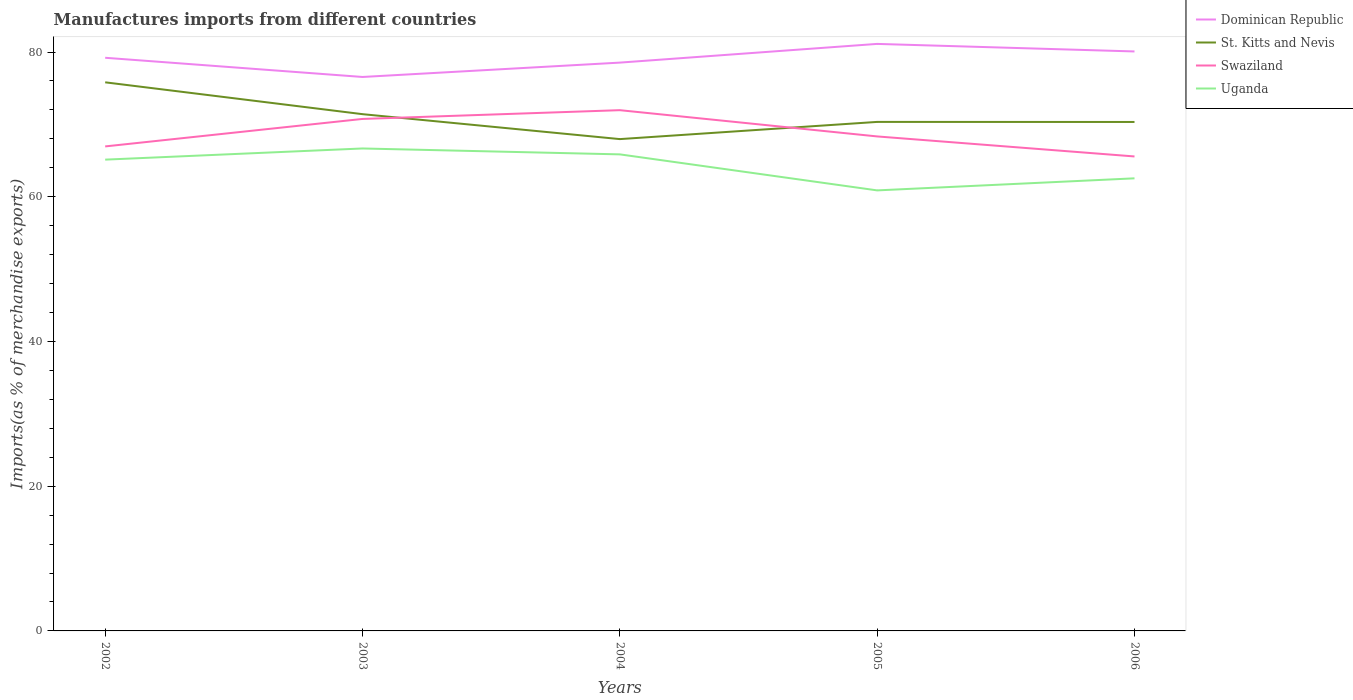Does the line corresponding to Uganda intersect with the line corresponding to St. Kitts and Nevis?
Ensure brevity in your answer.  No. Across all years, what is the maximum percentage of imports to different countries in St. Kitts and Nevis?
Offer a terse response. 67.97. What is the total percentage of imports to different countries in Swaziland in the graph?
Provide a succinct answer. -5.01. What is the difference between the highest and the second highest percentage of imports to different countries in Dominican Republic?
Provide a short and direct response. 4.57. Is the percentage of imports to different countries in St. Kitts and Nevis strictly greater than the percentage of imports to different countries in Dominican Republic over the years?
Make the answer very short. Yes. How many years are there in the graph?
Your response must be concise. 5. Are the values on the major ticks of Y-axis written in scientific E-notation?
Your response must be concise. No. What is the title of the graph?
Ensure brevity in your answer.  Manufactures imports from different countries. What is the label or title of the X-axis?
Offer a terse response. Years. What is the label or title of the Y-axis?
Give a very brief answer. Imports(as % of merchandise exports). What is the Imports(as % of merchandise exports) in Dominican Republic in 2002?
Offer a very short reply. 79.21. What is the Imports(as % of merchandise exports) of St. Kitts and Nevis in 2002?
Your answer should be very brief. 75.82. What is the Imports(as % of merchandise exports) of Swaziland in 2002?
Your response must be concise. 66.96. What is the Imports(as % of merchandise exports) in Uganda in 2002?
Your answer should be compact. 65.13. What is the Imports(as % of merchandise exports) of Dominican Republic in 2003?
Provide a succinct answer. 76.56. What is the Imports(as % of merchandise exports) in St. Kitts and Nevis in 2003?
Provide a short and direct response. 71.41. What is the Imports(as % of merchandise exports) of Swaziland in 2003?
Your answer should be compact. 70.76. What is the Imports(as % of merchandise exports) in Uganda in 2003?
Your response must be concise. 66.67. What is the Imports(as % of merchandise exports) in Dominican Republic in 2004?
Your answer should be compact. 78.54. What is the Imports(as % of merchandise exports) in St. Kitts and Nevis in 2004?
Your answer should be compact. 67.97. What is the Imports(as % of merchandise exports) of Swaziland in 2004?
Keep it short and to the point. 71.97. What is the Imports(as % of merchandise exports) of Uganda in 2004?
Offer a terse response. 65.86. What is the Imports(as % of merchandise exports) of Dominican Republic in 2005?
Offer a terse response. 81.12. What is the Imports(as % of merchandise exports) in St. Kitts and Nevis in 2005?
Your response must be concise. 70.34. What is the Imports(as % of merchandise exports) of Swaziland in 2005?
Provide a succinct answer. 68.34. What is the Imports(as % of merchandise exports) of Uganda in 2005?
Offer a terse response. 60.88. What is the Imports(as % of merchandise exports) of Dominican Republic in 2006?
Make the answer very short. 80.08. What is the Imports(as % of merchandise exports) of St. Kitts and Nevis in 2006?
Offer a terse response. 70.34. What is the Imports(as % of merchandise exports) of Swaziland in 2006?
Your answer should be compact. 65.57. What is the Imports(as % of merchandise exports) of Uganda in 2006?
Provide a succinct answer. 62.55. Across all years, what is the maximum Imports(as % of merchandise exports) of Dominican Republic?
Offer a very short reply. 81.12. Across all years, what is the maximum Imports(as % of merchandise exports) of St. Kitts and Nevis?
Offer a terse response. 75.82. Across all years, what is the maximum Imports(as % of merchandise exports) in Swaziland?
Your response must be concise. 71.97. Across all years, what is the maximum Imports(as % of merchandise exports) in Uganda?
Ensure brevity in your answer.  66.67. Across all years, what is the minimum Imports(as % of merchandise exports) in Dominican Republic?
Give a very brief answer. 76.56. Across all years, what is the minimum Imports(as % of merchandise exports) of St. Kitts and Nevis?
Keep it short and to the point. 67.97. Across all years, what is the minimum Imports(as % of merchandise exports) of Swaziland?
Offer a terse response. 65.57. Across all years, what is the minimum Imports(as % of merchandise exports) of Uganda?
Offer a very short reply. 60.88. What is the total Imports(as % of merchandise exports) of Dominican Republic in the graph?
Your answer should be compact. 395.51. What is the total Imports(as % of merchandise exports) of St. Kitts and Nevis in the graph?
Provide a succinct answer. 355.88. What is the total Imports(as % of merchandise exports) of Swaziland in the graph?
Ensure brevity in your answer.  343.59. What is the total Imports(as % of merchandise exports) in Uganda in the graph?
Provide a succinct answer. 321.09. What is the difference between the Imports(as % of merchandise exports) of Dominican Republic in 2002 and that in 2003?
Offer a very short reply. 2.65. What is the difference between the Imports(as % of merchandise exports) in St. Kitts and Nevis in 2002 and that in 2003?
Provide a succinct answer. 4.4. What is the difference between the Imports(as % of merchandise exports) in Swaziland in 2002 and that in 2003?
Keep it short and to the point. -3.8. What is the difference between the Imports(as % of merchandise exports) in Uganda in 2002 and that in 2003?
Your answer should be compact. -1.54. What is the difference between the Imports(as % of merchandise exports) of Dominican Republic in 2002 and that in 2004?
Make the answer very short. 0.67. What is the difference between the Imports(as % of merchandise exports) of St. Kitts and Nevis in 2002 and that in 2004?
Make the answer very short. 7.85. What is the difference between the Imports(as % of merchandise exports) in Swaziland in 2002 and that in 2004?
Your answer should be compact. -5.01. What is the difference between the Imports(as % of merchandise exports) in Uganda in 2002 and that in 2004?
Make the answer very short. -0.73. What is the difference between the Imports(as % of merchandise exports) in Dominican Republic in 2002 and that in 2005?
Provide a succinct answer. -1.92. What is the difference between the Imports(as % of merchandise exports) in St. Kitts and Nevis in 2002 and that in 2005?
Provide a succinct answer. 5.47. What is the difference between the Imports(as % of merchandise exports) in Swaziland in 2002 and that in 2005?
Offer a terse response. -1.38. What is the difference between the Imports(as % of merchandise exports) in Uganda in 2002 and that in 2005?
Provide a succinct answer. 4.25. What is the difference between the Imports(as % of merchandise exports) of Dominican Republic in 2002 and that in 2006?
Make the answer very short. -0.87. What is the difference between the Imports(as % of merchandise exports) of St. Kitts and Nevis in 2002 and that in 2006?
Provide a succinct answer. 5.48. What is the difference between the Imports(as % of merchandise exports) in Swaziland in 2002 and that in 2006?
Your answer should be very brief. 1.39. What is the difference between the Imports(as % of merchandise exports) in Uganda in 2002 and that in 2006?
Give a very brief answer. 2.58. What is the difference between the Imports(as % of merchandise exports) of Dominican Republic in 2003 and that in 2004?
Ensure brevity in your answer.  -1.98. What is the difference between the Imports(as % of merchandise exports) in St. Kitts and Nevis in 2003 and that in 2004?
Ensure brevity in your answer.  3.45. What is the difference between the Imports(as % of merchandise exports) in Swaziland in 2003 and that in 2004?
Provide a short and direct response. -1.21. What is the difference between the Imports(as % of merchandise exports) in Uganda in 2003 and that in 2004?
Give a very brief answer. 0.82. What is the difference between the Imports(as % of merchandise exports) in Dominican Republic in 2003 and that in 2005?
Ensure brevity in your answer.  -4.57. What is the difference between the Imports(as % of merchandise exports) in St. Kitts and Nevis in 2003 and that in 2005?
Make the answer very short. 1.07. What is the difference between the Imports(as % of merchandise exports) in Swaziland in 2003 and that in 2005?
Make the answer very short. 2.42. What is the difference between the Imports(as % of merchandise exports) in Uganda in 2003 and that in 2005?
Make the answer very short. 5.79. What is the difference between the Imports(as % of merchandise exports) of Dominican Republic in 2003 and that in 2006?
Your answer should be compact. -3.53. What is the difference between the Imports(as % of merchandise exports) in St. Kitts and Nevis in 2003 and that in 2006?
Give a very brief answer. 1.08. What is the difference between the Imports(as % of merchandise exports) in Swaziland in 2003 and that in 2006?
Ensure brevity in your answer.  5.19. What is the difference between the Imports(as % of merchandise exports) in Uganda in 2003 and that in 2006?
Give a very brief answer. 4.13. What is the difference between the Imports(as % of merchandise exports) in Dominican Republic in 2004 and that in 2005?
Your answer should be compact. -2.59. What is the difference between the Imports(as % of merchandise exports) of St. Kitts and Nevis in 2004 and that in 2005?
Offer a very short reply. -2.38. What is the difference between the Imports(as % of merchandise exports) of Swaziland in 2004 and that in 2005?
Offer a very short reply. 3.63. What is the difference between the Imports(as % of merchandise exports) of Uganda in 2004 and that in 2005?
Your answer should be compact. 4.98. What is the difference between the Imports(as % of merchandise exports) of Dominican Republic in 2004 and that in 2006?
Provide a succinct answer. -1.54. What is the difference between the Imports(as % of merchandise exports) of St. Kitts and Nevis in 2004 and that in 2006?
Provide a short and direct response. -2.37. What is the difference between the Imports(as % of merchandise exports) in Swaziland in 2004 and that in 2006?
Your response must be concise. 6.4. What is the difference between the Imports(as % of merchandise exports) in Uganda in 2004 and that in 2006?
Ensure brevity in your answer.  3.31. What is the difference between the Imports(as % of merchandise exports) in Dominican Republic in 2005 and that in 2006?
Your answer should be compact. 1.04. What is the difference between the Imports(as % of merchandise exports) in St. Kitts and Nevis in 2005 and that in 2006?
Offer a very short reply. 0.01. What is the difference between the Imports(as % of merchandise exports) in Swaziland in 2005 and that in 2006?
Your answer should be very brief. 2.77. What is the difference between the Imports(as % of merchandise exports) in Uganda in 2005 and that in 2006?
Provide a succinct answer. -1.67. What is the difference between the Imports(as % of merchandise exports) of Dominican Republic in 2002 and the Imports(as % of merchandise exports) of St. Kitts and Nevis in 2003?
Provide a succinct answer. 7.79. What is the difference between the Imports(as % of merchandise exports) of Dominican Republic in 2002 and the Imports(as % of merchandise exports) of Swaziland in 2003?
Give a very brief answer. 8.45. What is the difference between the Imports(as % of merchandise exports) of Dominican Republic in 2002 and the Imports(as % of merchandise exports) of Uganda in 2003?
Provide a succinct answer. 12.53. What is the difference between the Imports(as % of merchandise exports) in St. Kitts and Nevis in 2002 and the Imports(as % of merchandise exports) in Swaziland in 2003?
Make the answer very short. 5.06. What is the difference between the Imports(as % of merchandise exports) of St. Kitts and Nevis in 2002 and the Imports(as % of merchandise exports) of Uganda in 2003?
Your answer should be compact. 9.14. What is the difference between the Imports(as % of merchandise exports) in Swaziland in 2002 and the Imports(as % of merchandise exports) in Uganda in 2003?
Keep it short and to the point. 0.28. What is the difference between the Imports(as % of merchandise exports) in Dominican Republic in 2002 and the Imports(as % of merchandise exports) in St. Kitts and Nevis in 2004?
Give a very brief answer. 11.24. What is the difference between the Imports(as % of merchandise exports) of Dominican Republic in 2002 and the Imports(as % of merchandise exports) of Swaziland in 2004?
Your answer should be very brief. 7.24. What is the difference between the Imports(as % of merchandise exports) in Dominican Republic in 2002 and the Imports(as % of merchandise exports) in Uganda in 2004?
Ensure brevity in your answer.  13.35. What is the difference between the Imports(as % of merchandise exports) in St. Kitts and Nevis in 2002 and the Imports(as % of merchandise exports) in Swaziland in 2004?
Offer a very short reply. 3.85. What is the difference between the Imports(as % of merchandise exports) in St. Kitts and Nevis in 2002 and the Imports(as % of merchandise exports) in Uganda in 2004?
Offer a terse response. 9.96. What is the difference between the Imports(as % of merchandise exports) in Swaziland in 2002 and the Imports(as % of merchandise exports) in Uganda in 2004?
Your response must be concise. 1.1. What is the difference between the Imports(as % of merchandise exports) of Dominican Republic in 2002 and the Imports(as % of merchandise exports) of St. Kitts and Nevis in 2005?
Provide a succinct answer. 8.86. What is the difference between the Imports(as % of merchandise exports) of Dominican Republic in 2002 and the Imports(as % of merchandise exports) of Swaziland in 2005?
Give a very brief answer. 10.87. What is the difference between the Imports(as % of merchandise exports) of Dominican Republic in 2002 and the Imports(as % of merchandise exports) of Uganda in 2005?
Provide a succinct answer. 18.33. What is the difference between the Imports(as % of merchandise exports) of St. Kitts and Nevis in 2002 and the Imports(as % of merchandise exports) of Swaziland in 2005?
Provide a short and direct response. 7.48. What is the difference between the Imports(as % of merchandise exports) of St. Kitts and Nevis in 2002 and the Imports(as % of merchandise exports) of Uganda in 2005?
Ensure brevity in your answer.  14.94. What is the difference between the Imports(as % of merchandise exports) in Swaziland in 2002 and the Imports(as % of merchandise exports) in Uganda in 2005?
Provide a succinct answer. 6.08. What is the difference between the Imports(as % of merchandise exports) in Dominican Republic in 2002 and the Imports(as % of merchandise exports) in St. Kitts and Nevis in 2006?
Make the answer very short. 8.87. What is the difference between the Imports(as % of merchandise exports) in Dominican Republic in 2002 and the Imports(as % of merchandise exports) in Swaziland in 2006?
Your answer should be very brief. 13.64. What is the difference between the Imports(as % of merchandise exports) in Dominican Republic in 2002 and the Imports(as % of merchandise exports) in Uganda in 2006?
Your answer should be compact. 16.66. What is the difference between the Imports(as % of merchandise exports) of St. Kitts and Nevis in 2002 and the Imports(as % of merchandise exports) of Swaziland in 2006?
Ensure brevity in your answer.  10.25. What is the difference between the Imports(as % of merchandise exports) of St. Kitts and Nevis in 2002 and the Imports(as % of merchandise exports) of Uganda in 2006?
Provide a short and direct response. 13.27. What is the difference between the Imports(as % of merchandise exports) in Swaziland in 2002 and the Imports(as % of merchandise exports) in Uganda in 2006?
Your answer should be very brief. 4.41. What is the difference between the Imports(as % of merchandise exports) of Dominican Republic in 2003 and the Imports(as % of merchandise exports) of St. Kitts and Nevis in 2004?
Your answer should be compact. 8.59. What is the difference between the Imports(as % of merchandise exports) of Dominican Republic in 2003 and the Imports(as % of merchandise exports) of Swaziland in 2004?
Give a very brief answer. 4.59. What is the difference between the Imports(as % of merchandise exports) of Dominican Republic in 2003 and the Imports(as % of merchandise exports) of Uganda in 2004?
Your answer should be compact. 10.7. What is the difference between the Imports(as % of merchandise exports) in St. Kitts and Nevis in 2003 and the Imports(as % of merchandise exports) in Swaziland in 2004?
Provide a short and direct response. -0.55. What is the difference between the Imports(as % of merchandise exports) in St. Kitts and Nevis in 2003 and the Imports(as % of merchandise exports) in Uganda in 2004?
Give a very brief answer. 5.56. What is the difference between the Imports(as % of merchandise exports) of Swaziland in 2003 and the Imports(as % of merchandise exports) of Uganda in 2004?
Your answer should be compact. 4.9. What is the difference between the Imports(as % of merchandise exports) of Dominican Republic in 2003 and the Imports(as % of merchandise exports) of St. Kitts and Nevis in 2005?
Your answer should be very brief. 6.21. What is the difference between the Imports(as % of merchandise exports) in Dominican Republic in 2003 and the Imports(as % of merchandise exports) in Swaziland in 2005?
Give a very brief answer. 8.22. What is the difference between the Imports(as % of merchandise exports) in Dominican Republic in 2003 and the Imports(as % of merchandise exports) in Uganda in 2005?
Offer a very short reply. 15.68. What is the difference between the Imports(as % of merchandise exports) in St. Kitts and Nevis in 2003 and the Imports(as % of merchandise exports) in Swaziland in 2005?
Offer a terse response. 3.08. What is the difference between the Imports(as % of merchandise exports) of St. Kitts and Nevis in 2003 and the Imports(as % of merchandise exports) of Uganda in 2005?
Keep it short and to the point. 10.53. What is the difference between the Imports(as % of merchandise exports) of Swaziland in 2003 and the Imports(as % of merchandise exports) of Uganda in 2005?
Give a very brief answer. 9.88. What is the difference between the Imports(as % of merchandise exports) in Dominican Republic in 2003 and the Imports(as % of merchandise exports) in St. Kitts and Nevis in 2006?
Make the answer very short. 6.22. What is the difference between the Imports(as % of merchandise exports) of Dominican Republic in 2003 and the Imports(as % of merchandise exports) of Swaziland in 2006?
Give a very brief answer. 10.99. What is the difference between the Imports(as % of merchandise exports) in Dominican Republic in 2003 and the Imports(as % of merchandise exports) in Uganda in 2006?
Provide a succinct answer. 14.01. What is the difference between the Imports(as % of merchandise exports) in St. Kitts and Nevis in 2003 and the Imports(as % of merchandise exports) in Swaziland in 2006?
Give a very brief answer. 5.84. What is the difference between the Imports(as % of merchandise exports) of St. Kitts and Nevis in 2003 and the Imports(as % of merchandise exports) of Uganda in 2006?
Ensure brevity in your answer.  8.87. What is the difference between the Imports(as % of merchandise exports) of Swaziland in 2003 and the Imports(as % of merchandise exports) of Uganda in 2006?
Your answer should be very brief. 8.21. What is the difference between the Imports(as % of merchandise exports) in Dominican Republic in 2004 and the Imports(as % of merchandise exports) in St. Kitts and Nevis in 2005?
Provide a succinct answer. 8.2. What is the difference between the Imports(as % of merchandise exports) in Dominican Republic in 2004 and the Imports(as % of merchandise exports) in Swaziland in 2005?
Your answer should be compact. 10.2. What is the difference between the Imports(as % of merchandise exports) in Dominican Republic in 2004 and the Imports(as % of merchandise exports) in Uganda in 2005?
Provide a succinct answer. 17.66. What is the difference between the Imports(as % of merchandise exports) of St. Kitts and Nevis in 2004 and the Imports(as % of merchandise exports) of Swaziland in 2005?
Make the answer very short. -0.37. What is the difference between the Imports(as % of merchandise exports) in St. Kitts and Nevis in 2004 and the Imports(as % of merchandise exports) in Uganda in 2005?
Provide a short and direct response. 7.09. What is the difference between the Imports(as % of merchandise exports) in Swaziland in 2004 and the Imports(as % of merchandise exports) in Uganda in 2005?
Give a very brief answer. 11.09. What is the difference between the Imports(as % of merchandise exports) of Dominican Republic in 2004 and the Imports(as % of merchandise exports) of St. Kitts and Nevis in 2006?
Offer a terse response. 8.2. What is the difference between the Imports(as % of merchandise exports) of Dominican Republic in 2004 and the Imports(as % of merchandise exports) of Swaziland in 2006?
Your response must be concise. 12.97. What is the difference between the Imports(as % of merchandise exports) in Dominican Republic in 2004 and the Imports(as % of merchandise exports) in Uganda in 2006?
Offer a terse response. 15.99. What is the difference between the Imports(as % of merchandise exports) of St. Kitts and Nevis in 2004 and the Imports(as % of merchandise exports) of Swaziland in 2006?
Give a very brief answer. 2.4. What is the difference between the Imports(as % of merchandise exports) in St. Kitts and Nevis in 2004 and the Imports(as % of merchandise exports) in Uganda in 2006?
Your answer should be compact. 5.42. What is the difference between the Imports(as % of merchandise exports) in Swaziland in 2004 and the Imports(as % of merchandise exports) in Uganda in 2006?
Your answer should be compact. 9.42. What is the difference between the Imports(as % of merchandise exports) of Dominican Republic in 2005 and the Imports(as % of merchandise exports) of St. Kitts and Nevis in 2006?
Offer a very short reply. 10.79. What is the difference between the Imports(as % of merchandise exports) of Dominican Republic in 2005 and the Imports(as % of merchandise exports) of Swaziland in 2006?
Keep it short and to the point. 15.55. What is the difference between the Imports(as % of merchandise exports) in Dominican Republic in 2005 and the Imports(as % of merchandise exports) in Uganda in 2006?
Your response must be concise. 18.58. What is the difference between the Imports(as % of merchandise exports) of St. Kitts and Nevis in 2005 and the Imports(as % of merchandise exports) of Swaziland in 2006?
Your answer should be very brief. 4.77. What is the difference between the Imports(as % of merchandise exports) of St. Kitts and Nevis in 2005 and the Imports(as % of merchandise exports) of Uganda in 2006?
Your answer should be compact. 7.8. What is the difference between the Imports(as % of merchandise exports) of Swaziland in 2005 and the Imports(as % of merchandise exports) of Uganda in 2006?
Offer a very short reply. 5.79. What is the average Imports(as % of merchandise exports) in Dominican Republic per year?
Your response must be concise. 79.1. What is the average Imports(as % of merchandise exports) in St. Kitts and Nevis per year?
Provide a succinct answer. 71.18. What is the average Imports(as % of merchandise exports) in Swaziland per year?
Your response must be concise. 68.72. What is the average Imports(as % of merchandise exports) of Uganda per year?
Provide a succinct answer. 64.22. In the year 2002, what is the difference between the Imports(as % of merchandise exports) in Dominican Republic and Imports(as % of merchandise exports) in St. Kitts and Nevis?
Offer a very short reply. 3.39. In the year 2002, what is the difference between the Imports(as % of merchandise exports) in Dominican Republic and Imports(as % of merchandise exports) in Swaziland?
Provide a short and direct response. 12.25. In the year 2002, what is the difference between the Imports(as % of merchandise exports) in Dominican Republic and Imports(as % of merchandise exports) in Uganda?
Provide a short and direct response. 14.08. In the year 2002, what is the difference between the Imports(as % of merchandise exports) of St. Kitts and Nevis and Imports(as % of merchandise exports) of Swaziland?
Offer a very short reply. 8.86. In the year 2002, what is the difference between the Imports(as % of merchandise exports) of St. Kitts and Nevis and Imports(as % of merchandise exports) of Uganda?
Keep it short and to the point. 10.68. In the year 2002, what is the difference between the Imports(as % of merchandise exports) of Swaziland and Imports(as % of merchandise exports) of Uganda?
Offer a very short reply. 1.83. In the year 2003, what is the difference between the Imports(as % of merchandise exports) of Dominican Republic and Imports(as % of merchandise exports) of St. Kitts and Nevis?
Offer a very short reply. 5.14. In the year 2003, what is the difference between the Imports(as % of merchandise exports) of Dominican Republic and Imports(as % of merchandise exports) of Swaziland?
Give a very brief answer. 5.8. In the year 2003, what is the difference between the Imports(as % of merchandise exports) of Dominican Republic and Imports(as % of merchandise exports) of Uganda?
Offer a very short reply. 9.88. In the year 2003, what is the difference between the Imports(as % of merchandise exports) of St. Kitts and Nevis and Imports(as % of merchandise exports) of Swaziland?
Offer a very short reply. 0.66. In the year 2003, what is the difference between the Imports(as % of merchandise exports) in St. Kitts and Nevis and Imports(as % of merchandise exports) in Uganda?
Give a very brief answer. 4.74. In the year 2003, what is the difference between the Imports(as % of merchandise exports) of Swaziland and Imports(as % of merchandise exports) of Uganda?
Provide a short and direct response. 4.08. In the year 2004, what is the difference between the Imports(as % of merchandise exports) in Dominican Republic and Imports(as % of merchandise exports) in St. Kitts and Nevis?
Your answer should be compact. 10.57. In the year 2004, what is the difference between the Imports(as % of merchandise exports) in Dominican Republic and Imports(as % of merchandise exports) in Swaziland?
Your response must be concise. 6.57. In the year 2004, what is the difference between the Imports(as % of merchandise exports) in Dominican Republic and Imports(as % of merchandise exports) in Uganda?
Give a very brief answer. 12.68. In the year 2004, what is the difference between the Imports(as % of merchandise exports) of St. Kitts and Nevis and Imports(as % of merchandise exports) of Swaziland?
Your response must be concise. -4. In the year 2004, what is the difference between the Imports(as % of merchandise exports) in St. Kitts and Nevis and Imports(as % of merchandise exports) in Uganda?
Provide a short and direct response. 2.11. In the year 2004, what is the difference between the Imports(as % of merchandise exports) of Swaziland and Imports(as % of merchandise exports) of Uganda?
Make the answer very short. 6.11. In the year 2005, what is the difference between the Imports(as % of merchandise exports) in Dominican Republic and Imports(as % of merchandise exports) in St. Kitts and Nevis?
Give a very brief answer. 10.78. In the year 2005, what is the difference between the Imports(as % of merchandise exports) in Dominican Republic and Imports(as % of merchandise exports) in Swaziland?
Keep it short and to the point. 12.79. In the year 2005, what is the difference between the Imports(as % of merchandise exports) in Dominican Republic and Imports(as % of merchandise exports) in Uganda?
Make the answer very short. 20.24. In the year 2005, what is the difference between the Imports(as % of merchandise exports) of St. Kitts and Nevis and Imports(as % of merchandise exports) of Swaziland?
Your response must be concise. 2.01. In the year 2005, what is the difference between the Imports(as % of merchandise exports) in St. Kitts and Nevis and Imports(as % of merchandise exports) in Uganda?
Provide a succinct answer. 9.46. In the year 2005, what is the difference between the Imports(as % of merchandise exports) in Swaziland and Imports(as % of merchandise exports) in Uganda?
Your answer should be compact. 7.46. In the year 2006, what is the difference between the Imports(as % of merchandise exports) in Dominican Republic and Imports(as % of merchandise exports) in St. Kitts and Nevis?
Your answer should be compact. 9.75. In the year 2006, what is the difference between the Imports(as % of merchandise exports) of Dominican Republic and Imports(as % of merchandise exports) of Swaziland?
Keep it short and to the point. 14.51. In the year 2006, what is the difference between the Imports(as % of merchandise exports) in Dominican Republic and Imports(as % of merchandise exports) in Uganda?
Provide a short and direct response. 17.53. In the year 2006, what is the difference between the Imports(as % of merchandise exports) in St. Kitts and Nevis and Imports(as % of merchandise exports) in Swaziland?
Make the answer very short. 4.77. In the year 2006, what is the difference between the Imports(as % of merchandise exports) of St. Kitts and Nevis and Imports(as % of merchandise exports) of Uganda?
Make the answer very short. 7.79. In the year 2006, what is the difference between the Imports(as % of merchandise exports) of Swaziland and Imports(as % of merchandise exports) of Uganda?
Give a very brief answer. 3.02. What is the ratio of the Imports(as % of merchandise exports) of Dominican Republic in 2002 to that in 2003?
Your answer should be compact. 1.03. What is the ratio of the Imports(as % of merchandise exports) in St. Kitts and Nevis in 2002 to that in 2003?
Ensure brevity in your answer.  1.06. What is the ratio of the Imports(as % of merchandise exports) of Swaziland in 2002 to that in 2003?
Your answer should be compact. 0.95. What is the ratio of the Imports(as % of merchandise exports) in Uganda in 2002 to that in 2003?
Ensure brevity in your answer.  0.98. What is the ratio of the Imports(as % of merchandise exports) in Dominican Republic in 2002 to that in 2004?
Keep it short and to the point. 1.01. What is the ratio of the Imports(as % of merchandise exports) in St. Kitts and Nevis in 2002 to that in 2004?
Provide a succinct answer. 1.12. What is the ratio of the Imports(as % of merchandise exports) of Swaziland in 2002 to that in 2004?
Ensure brevity in your answer.  0.93. What is the ratio of the Imports(as % of merchandise exports) in Uganda in 2002 to that in 2004?
Give a very brief answer. 0.99. What is the ratio of the Imports(as % of merchandise exports) in Dominican Republic in 2002 to that in 2005?
Your response must be concise. 0.98. What is the ratio of the Imports(as % of merchandise exports) of St. Kitts and Nevis in 2002 to that in 2005?
Make the answer very short. 1.08. What is the ratio of the Imports(as % of merchandise exports) in Swaziland in 2002 to that in 2005?
Your answer should be compact. 0.98. What is the ratio of the Imports(as % of merchandise exports) in Uganda in 2002 to that in 2005?
Keep it short and to the point. 1.07. What is the ratio of the Imports(as % of merchandise exports) of Dominican Republic in 2002 to that in 2006?
Your answer should be very brief. 0.99. What is the ratio of the Imports(as % of merchandise exports) in St. Kitts and Nevis in 2002 to that in 2006?
Offer a terse response. 1.08. What is the ratio of the Imports(as % of merchandise exports) in Swaziland in 2002 to that in 2006?
Provide a short and direct response. 1.02. What is the ratio of the Imports(as % of merchandise exports) in Uganda in 2002 to that in 2006?
Give a very brief answer. 1.04. What is the ratio of the Imports(as % of merchandise exports) of Dominican Republic in 2003 to that in 2004?
Your answer should be compact. 0.97. What is the ratio of the Imports(as % of merchandise exports) in St. Kitts and Nevis in 2003 to that in 2004?
Make the answer very short. 1.05. What is the ratio of the Imports(as % of merchandise exports) of Swaziland in 2003 to that in 2004?
Make the answer very short. 0.98. What is the ratio of the Imports(as % of merchandise exports) in Uganda in 2003 to that in 2004?
Your answer should be compact. 1.01. What is the ratio of the Imports(as % of merchandise exports) in Dominican Republic in 2003 to that in 2005?
Your answer should be very brief. 0.94. What is the ratio of the Imports(as % of merchandise exports) of St. Kitts and Nevis in 2003 to that in 2005?
Provide a short and direct response. 1.02. What is the ratio of the Imports(as % of merchandise exports) of Swaziland in 2003 to that in 2005?
Ensure brevity in your answer.  1.04. What is the ratio of the Imports(as % of merchandise exports) of Uganda in 2003 to that in 2005?
Your answer should be compact. 1.1. What is the ratio of the Imports(as % of merchandise exports) of Dominican Republic in 2003 to that in 2006?
Your response must be concise. 0.96. What is the ratio of the Imports(as % of merchandise exports) of St. Kitts and Nevis in 2003 to that in 2006?
Make the answer very short. 1.02. What is the ratio of the Imports(as % of merchandise exports) in Swaziland in 2003 to that in 2006?
Offer a terse response. 1.08. What is the ratio of the Imports(as % of merchandise exports) in Uganda in 2003 to that in 2006?
Keep it short and to the point. 1.07. What is the ratio of the Imports(as % of merchandise exports) of Dominican Republic in 2004 to that in 2005?
Ensure brevity in your answer.  0.97. What is the ratio of the Imports(as % of merchandise exports) in St. Kitts and Nevis in 2004 to that in 2005?
Keep it short and to the point. 0.97. What is the ratio of the Imports(as % of merchandise exports) in Swaziland in 2004 to that in 2005?
Ensure brevity in your answer.  1.05. What is the ratio of the Imports(as % of merchandise exports) in Uganda in 2004 to that in 2005?
Ensure brevity in your answer.  1.08. What is the ratio of the Imports(as % of merchandise exports) in Dominican Republic in 2004 to that in 2006?
Make the answer very short. 0.98. What is the ratio of the Imports(as % of merchandise exports) in St. Kitts and Nevis in 2004 to that in 2006?
Make the answer very short. 0.97. What is the ratio of the Imports(as % of merchandise exports) of Swaziland in 2004 to that in 2006?
Keep it short and to the point. 1.1. What is the ratio of the Imports(as % of merchandise exports) in Uganda in 2004 to that in 2006?
Keep it short and to the point. 1.05. What is the ratio of the Imports(as % of merchandise exports) of St. Kitts and Nevis in 2005 to that in 2006?
Provide a succinct answer. 1. What is the ratio of the Imports(as % of merchandise exports) of Swaziland in 2005 to that in 2006?
Keep it short and to the point. 1.04. What is the ratio of the Imports(as % of merchandise exports) in Uganda in 2005 to that in 2006?
Your response must be concise. 0.97. What is the difference between the highest and the second highest Imports(as % of merchandise exports) in Dominican Republic?
Offer a terse response. 1.04. What is the difference between the highest and the second highest Imports(as % of merchandise exports) of St. Kitts and Nevis?
Offer a terse response. 4.4. What is the difference between the highest and the second highest Imports(as % of merchandise exports) in Swaziland?
Keep it short and to the point. 1.21. What is the difference between the highest and the second highest Imports(as % of merchandise exports) in Uganda?
Ensure brevity in your answer.  0.82. What is the difference between the highest and the lowest Imports(as % of merchandise exports) of Dominican Republic?
Your answer should be very brief. 4.57. What is the difference between the highest and the lowest Imports(as % of merchandise exports) of St. Kitts and Nevis?
Offer a very short reply. 7.85. What is the difference between the highest and the lowest Imports(as % of merchandise exports) in Swaziland?
Make the answer very short. 6.4. What is the difference between the highest and the lowest Imports(as % of merchandise exports) of Uganda?
Your response must be concise. 5.79. 